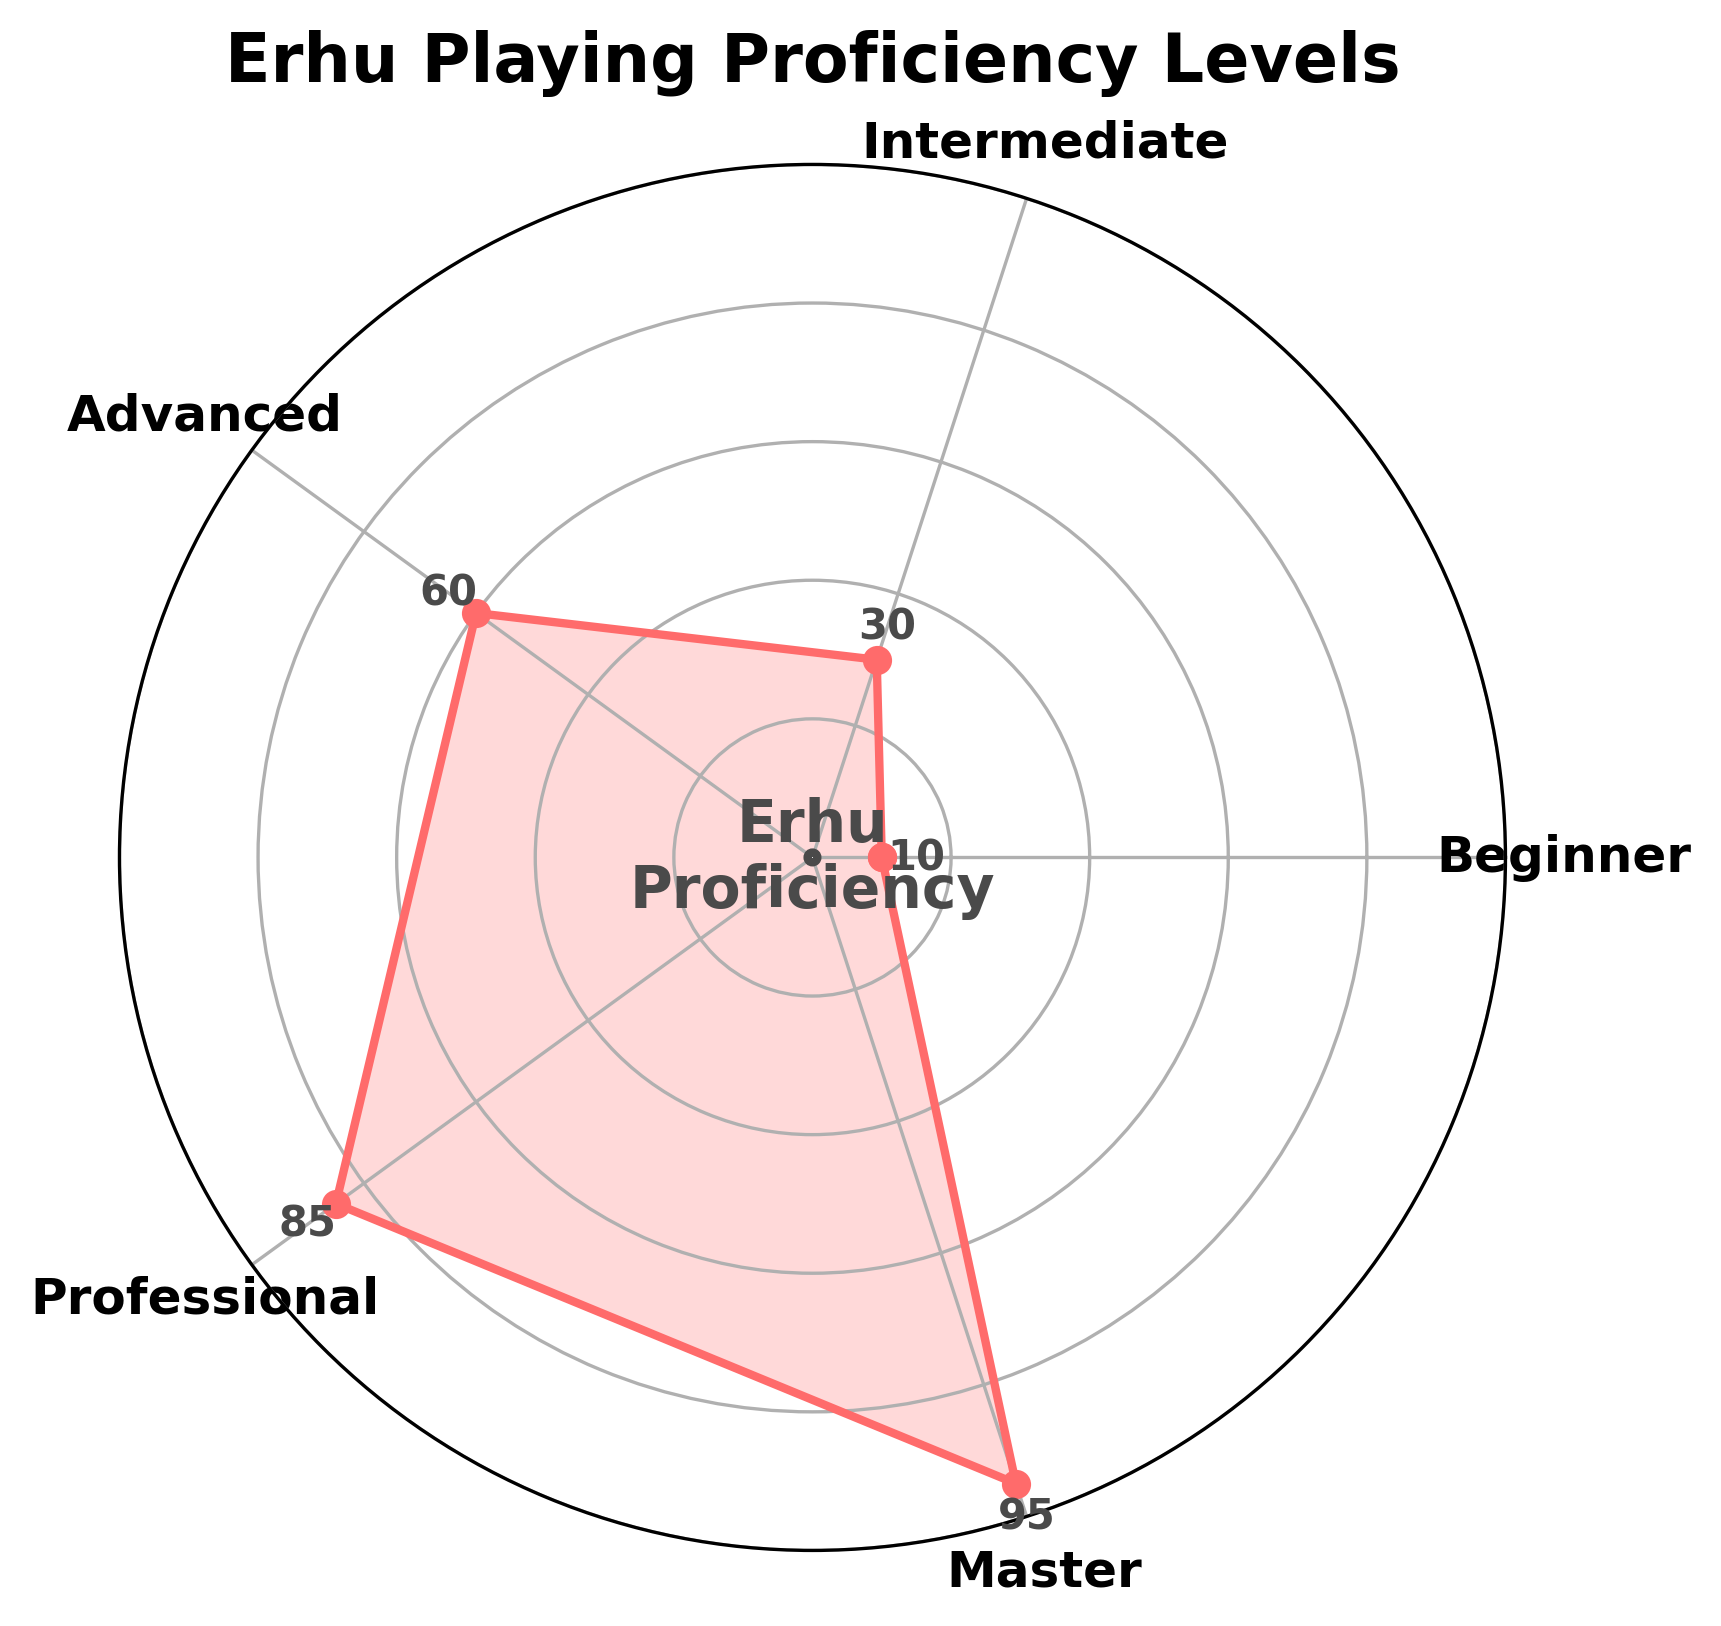What is the title of the plot? The title is displayed at the top of the plot with larger and bold font.
Answer: Erhu Playing Proficiency Levels How many proficiency levels are represented on the chart? Each level is labeled around the circumference of the chart.
Answer: 5 What is the proficiency value for the 'Advanced' level? Each level is accompanied by a numeric value displayed next to the level label on the circumference.
Answer: 60 Which proficiency level has the highest value? The level with the highest numeric value next to its label on the chart.
Answer: Master Which two proficiency levels have the closest values? Compare the differences between the values of adjacent levels to find the smallest difference.
Answer: Advanced and Professional (85 - 60 = 25) What is the average value of all proficiency levels? Add all the values and divide by the number of levels: (10 + 30 + 60 + 85 + 95) / 5 = 56
Answer: 56 Which proficiency level is exactly in the middle of the scale from 0 to 100? Find the level with a value closest to 50.
Answer: Intermediate What is the unique feature of the circle at the center of the chart? Describe any text or design elements inside the center circle.
Answer: It contains the text "Erhu Proficiency" 